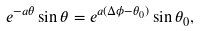Convert formula to latex. <formula><loc_0><loc_0><loc_500><loc_500>e ^ { - a \theta } \sin \theta = e ^ { a ( \Delta \phi - \theta _ { 0 } ) } \sin \theta _ { 0 } ,</formula> 